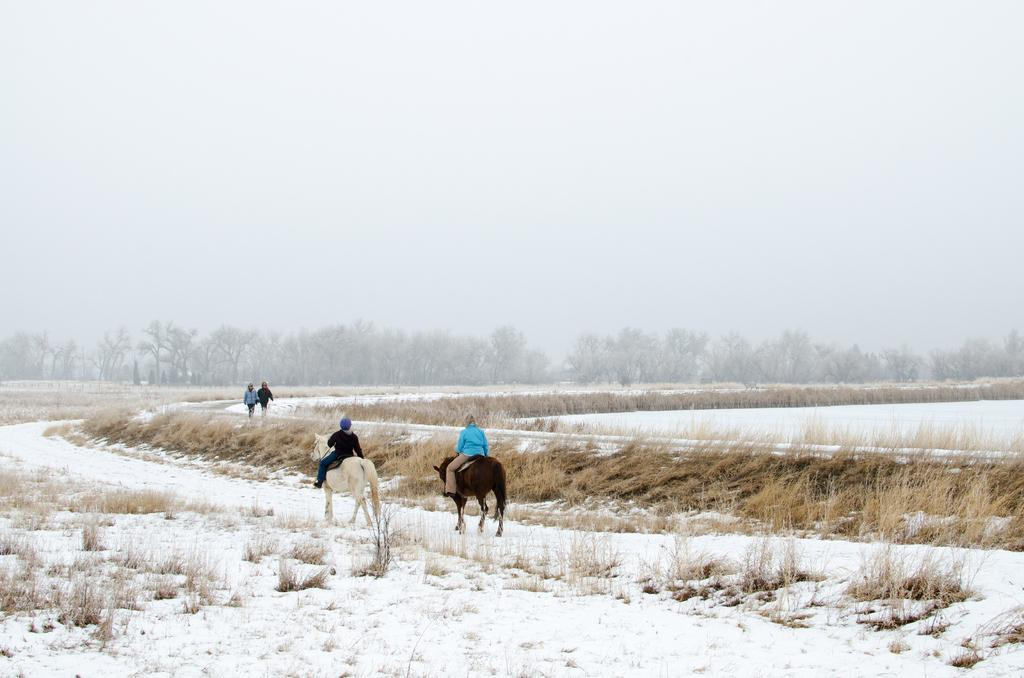What type of vegetation is present in the image? There is dry grass in the image. Who or what else can be seen in the image? There are people and horses in the image. What can be seen in the background of the image? There are trees in the background of the image. What is visible at the top of the image? The sky is visible at the top of the image. What type of punishment is being given to the ants in the image? There are no ants present in the image, so there is no punishment being given to them. 